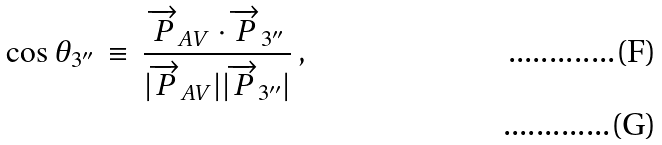<formula> <loc_0><loc_0><loc_500><loc_500>\cos \theta _ { 3 ^ { \prime \prime } } \, \equiv \, \frac { \overrightarrow { P } _ { A V } \cdot \overrightarrow { P } _ { 3 ^ { \prime \prime } } } { | \overrightarrow { P } _ { A V } | | \overrightarrow { P } _ { 3 ^ { \prime \prime } } | } \, , \\</formula> 